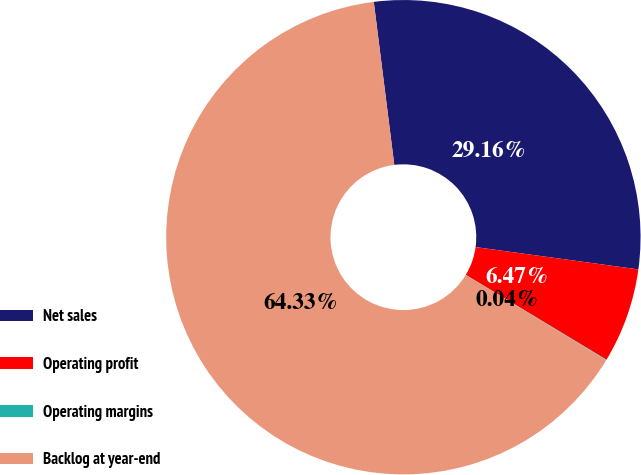<chart> <loc_0><loc_0><loc_500><loc_500><pie_chart><fcel>Net sales<fcel>Operating profit<fcel>Operating margins<fcel>Backlog at year-end<nl><fcel>29.16%<fcel>6.47%<fcel>0.04%<fcel>64.33%<nl></chart> 